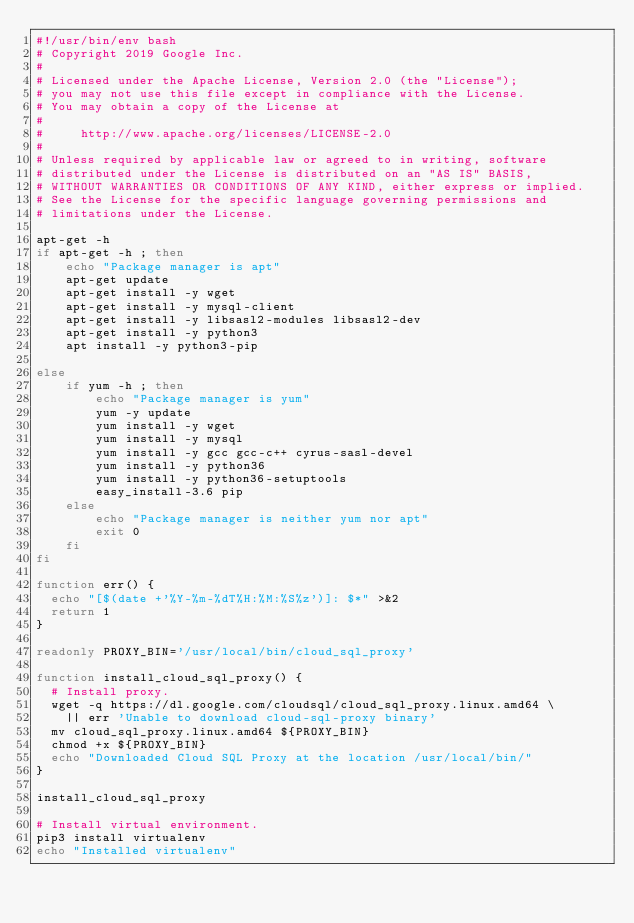Convert code to text. <code><loc_0><loc_0><loc_500><loc_500><_Bash_>#!/usr/bin/env bash
# Copyright 2019 Google Inc.
#
# Licensed under the Apache License, Version 2.0 (the "License");
# you may not use this file except in compliance with the License.
# You may obtain a copy of the License at
#
#     http://www.apache.org/licenses/LICENSE-2.0
#
# Unless required by applicable law or agreed to in writing, software
# distributed under the License is distributed on an "AS IS" BASIS,
# WITHOUT WARRANTIES OR CONDITIONS OF ANY KIND, either express or implied.
# See the License for the specific language governing permissions and
# limitations under the License.

apt-get -h
if apt-get -h ; then
    echo "Package manager is apt"
    apt-get update
    apt-get install -y wget
    apt-get install -y mysql-client
    apt-get install -y libsasl2-modules libsasl2-dev
    apt-get install -y python3
    apt install -y python3-pip

else
    if yum -h ; then
        echo "Package manager is yum"
        yum -y update
        yum install -y wget
        yum install -y mysql
        yum install -y gcc gcc-c++ cyrus-sasl-devel
        yum install -y python36
        yum install -y python36-setuptools
        easy_install-3.6 pip
    else
        echo "Package manager is neither yum nor apt"
        exit 0
    fi
fi

function err() {
  echo "[$(date +'%Y-%m-%dT%H:%M:%S%z')]: $*" >&2
  return 1
}

readonly PROXY_BIN='/usr/local/bin/cloud_sql_proxy'

function install_cloud_sql_proxy() {
  # Install proxy.
  wget -q https://dl.google.com/cloudsql/cloud_sql_proxy.linux.amd64 \
    || err 'Unable to download cloud-sql-proxy binary'
  mv cloud_sql_proxy.linux.amd64 ${PROXY_BIN}
  chmod +x ${PROXY_BIN}
  echo "Downloaded Cloud SQL Proxy at the location /usr/local/bin/"
}

install_cloud_sql_proxy

# Install virtual environment.
pip3 install virtualenv
echo "Installed virtualenv"</code> 